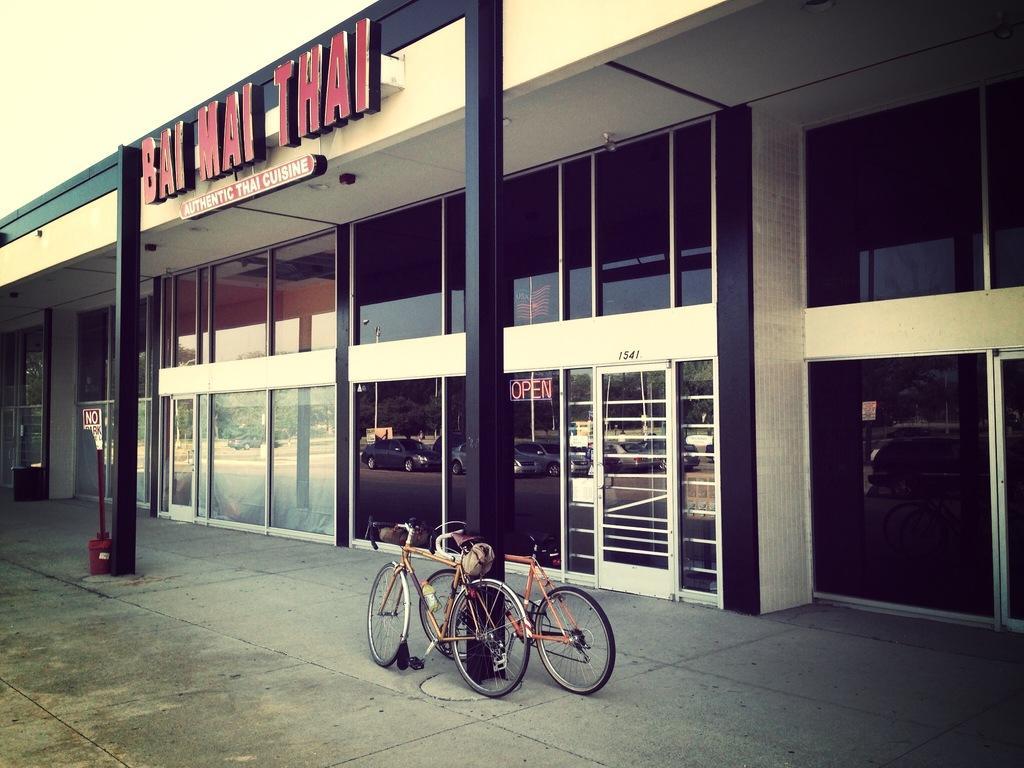Please provide a concise description of this image. In the middle of the picture, we see two bicycles. Beside that, we see a pole. On the left side, we see a pole and a board in white and red color with some text written on it. In this picture, we see a building in white and black color. It has glass doors and windows. We see the trees and the cars moving on the road in the glass windows. On top of the building, we see some text written. In the left top, we see the sky. 